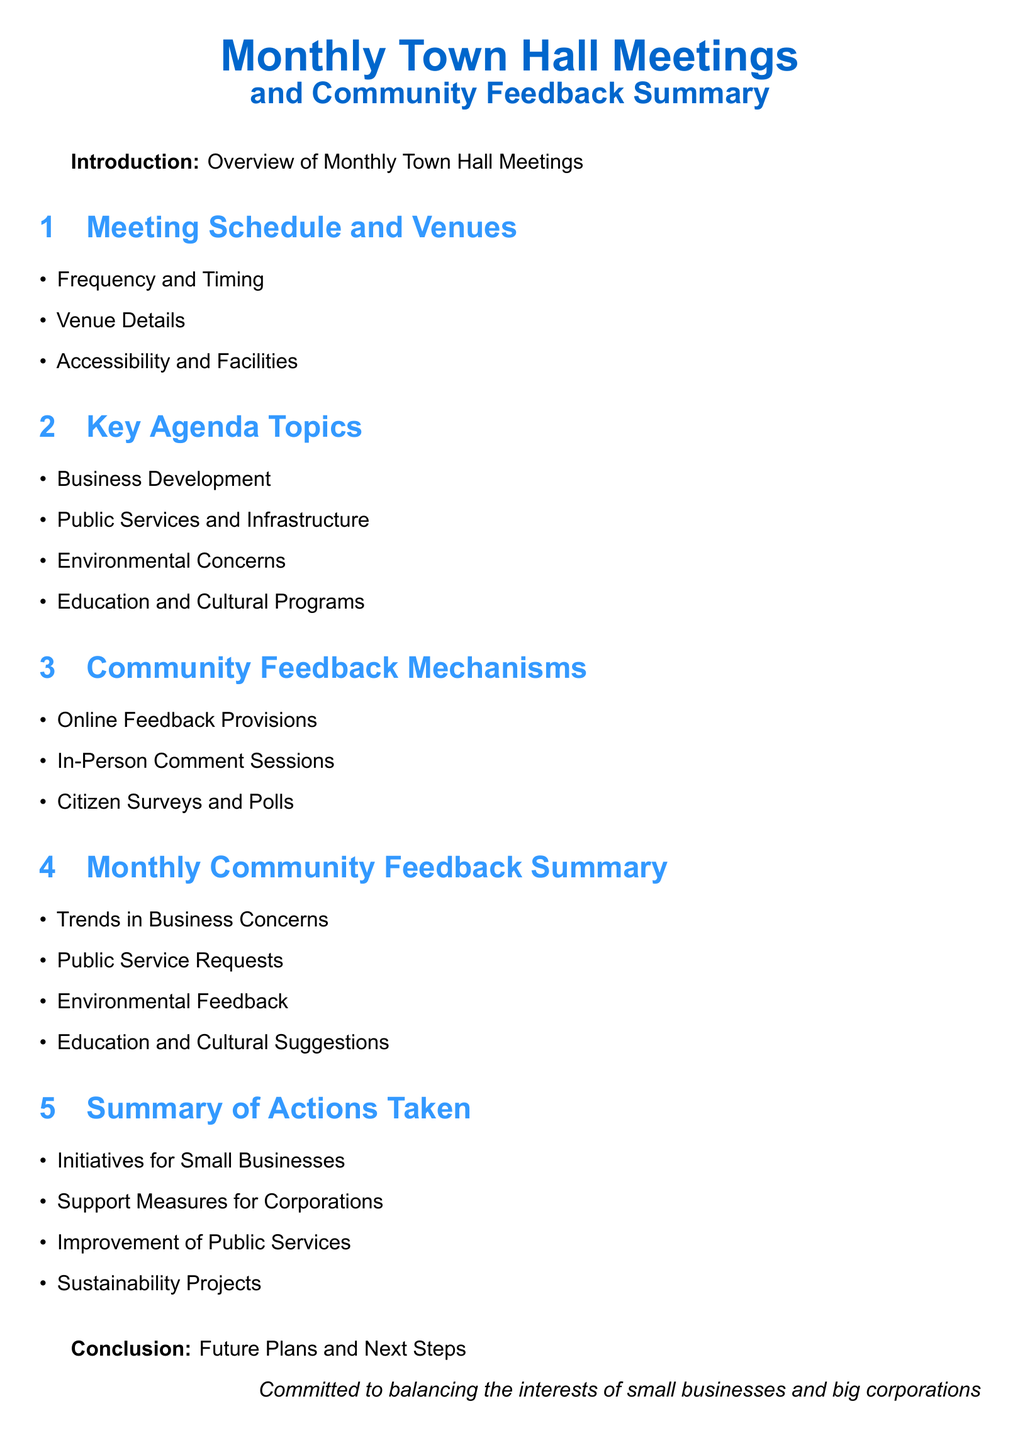what is the frequency of the meetings? The document mentions the frequency of the meetings under the Meeting Schedule and Venues section.
Answer: Monthly what are the key agenda topics? The key agenda topics are listed in a bullet point format.
Answer: Business Development, Public Services and Infrastructure, Environmental Concerns, Education and Cultural Programs what mechanisms are used for community feedback? The document outlines several mechanisms in the Community Feedback Mechanisms section.
Answer: Online Feedback Provisions, In-Person Comment Sessions, Citizen Surveys and Polls what trends are included in the Monthly Community Feedback Summary? Trends discussed in the summary focus on various community concerns, listed under the Monthly Community Feedback Summary section.
Answer: Trends in Business Concerns, Public Service Requests, Environmental Feedback, Education and Cultural Suggestions what initiatives are taken for small businesses? The action summary mentions specific initiatives aimed at small businesses as part of the summary of actions taken.
Answer: Initiatives for Small Businesses what is stated about future plans? Future plans and next steps are briefly mentioned in the conclusion.
Answer: Future Plans and Next Steps 